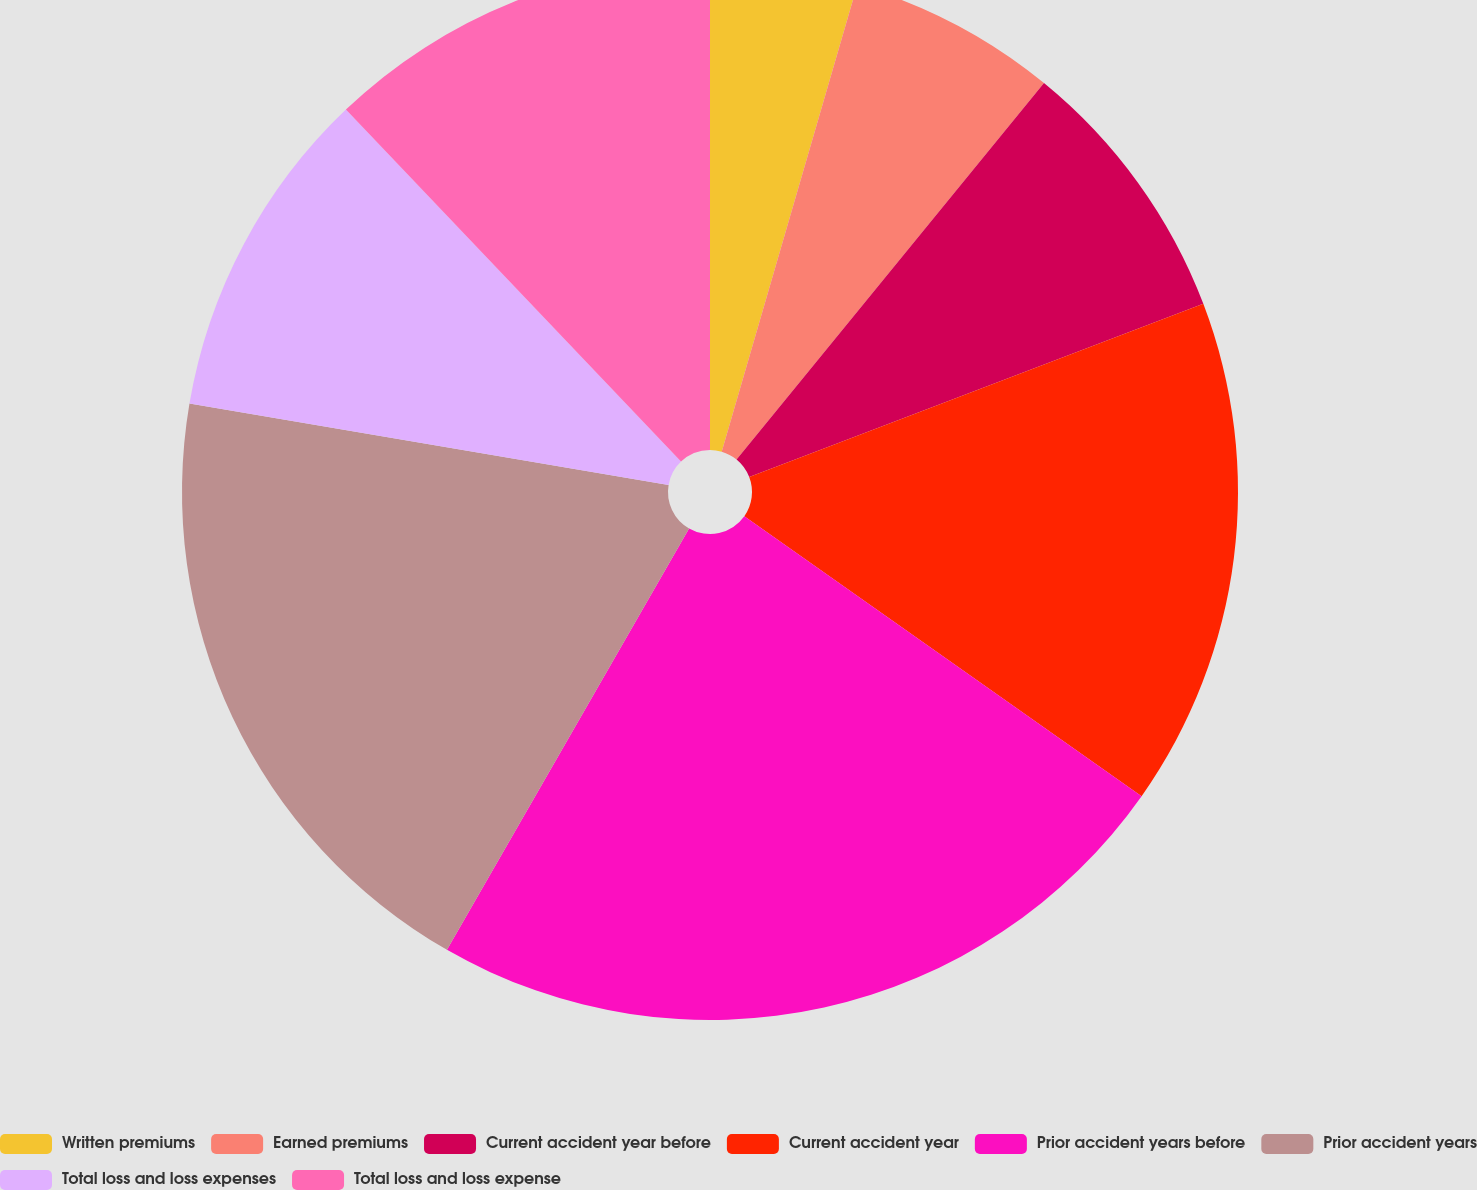<chart> <loc_0><loc_0><loc_500><loc_500><pie_chart><fcel>Written premiums<fcel>Earned premiums<fcel>Current accident year before<fcel>Current accident year<fcel>Prior accident years before<fcel>Prior accident years<fcel>Total loss and loss expenses<fcel>Total loss and loss expense<nl><fcel>4.5%<fcel>6.4%<fcel>8.3%<fcel>15.57%<fcel>23.53%<fcel>19.38%<fcel>10.21%<fcel>12.11%<nl></chart> 